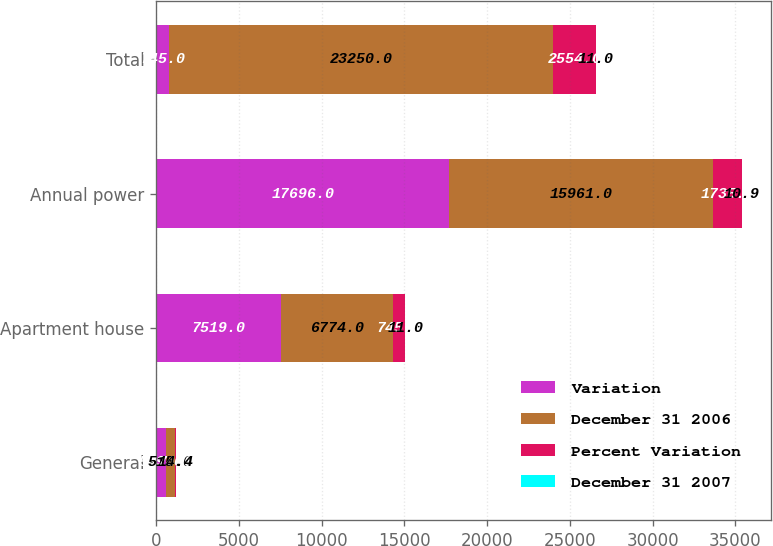Convert chart to OTSL. <chart><loc_0><loc_0><loc_500><loc_500><stacked_bar_chart><ecel><fcel>General<fcel>Apartment house<fcel>Annual power<fcel>Total<nl><fcel>Variation<fcel>589<fcel>7519<fcel>17696<fcel>745<nl><fcel>December 31 2006<fcel>515<fcel>6774<fcel>15961<fcel>23250<nl><fcel>Percent Variation<fcel>74<fcel>745<fcel>1735<fcel>2554<nl><fcel>December 31 2007<fcel>14.4<fcel>11<fcel>10.9<fcel>11<nl></chart> 